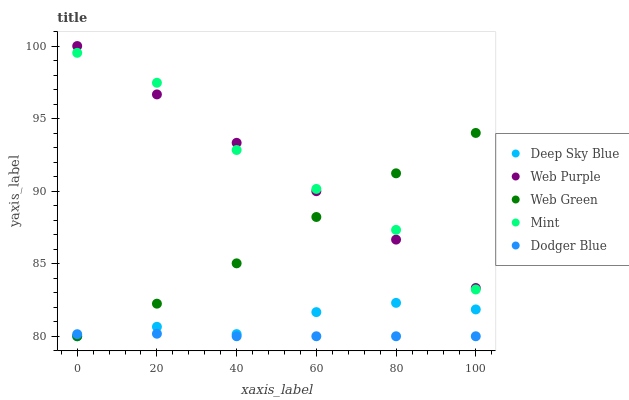Does Dodger Blue have the minimum area under the curve?
Answer yes or no. Yes. Does Mint have the maximum area under the curve?
Answer yes or no. Yes. Does Web Purple have the minimum area under the curve?
Answer yes or no. No. Does Web Purple have the maximum area under the curve?
Answer yes or no. No. Is Web Purple the smoothest?
Answer yes or no. Yes. Is Mint the roughest?
Answer yes or no. Yes. Is Mint the smoothest?
Answer yes or no. No. Is Web Purple the roughest?
Answer yes or no. No. Does Dodger Blue have the lowest value?
Answer yes or no. Yes. Does Mint have the lowest value?
Answer yes or no. No. Does Web Purple have the highest value?
Answer yes or no. Yes. Does Mint have the highest value?
Answer yes or no. No. Is Deep Sky Blue less than Web Purple?
Answer yes or no. Yes. Is Mint greater than Dodger Blue?
Answer yes or no. Yes. Does Mint intersect Web Purple?
Answer yes or no. Yes. Is Mint less than Web Purple?
Answer yes or no. No. Is Mint greater than Web Purple?
Answer yes or no. No. Does Deep Sky Blue intersect Web Purple?
Answer yes or no. No. 